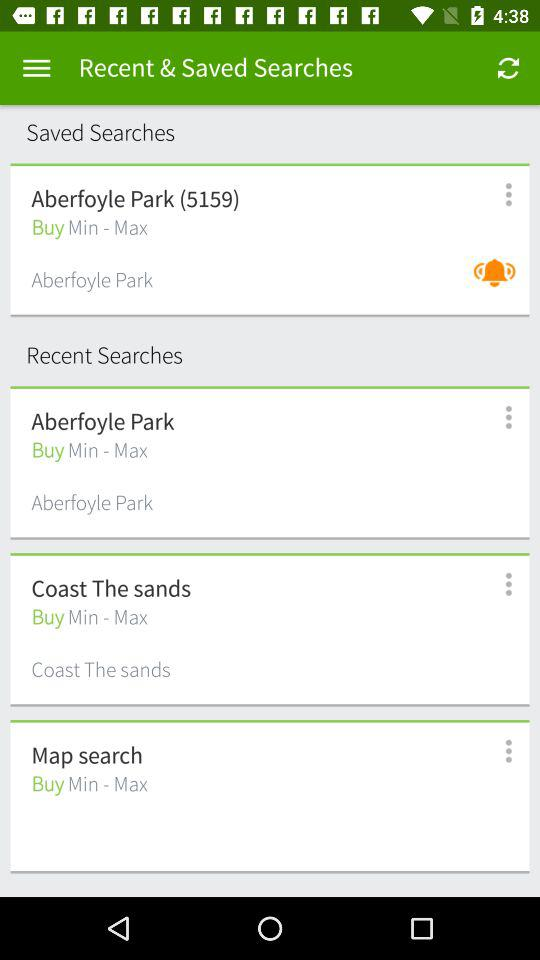What are the recent searches? The recent searches are Aberfoyle Park, Coast The Sands and Map search. 